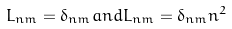<formula> <loc_0><loc_0><loc_500><loc_500>L _ { n m } = \delta _ { n m } a n d L _ { n m } = \delta _ { n m } n ^ { 2 }</formula> 